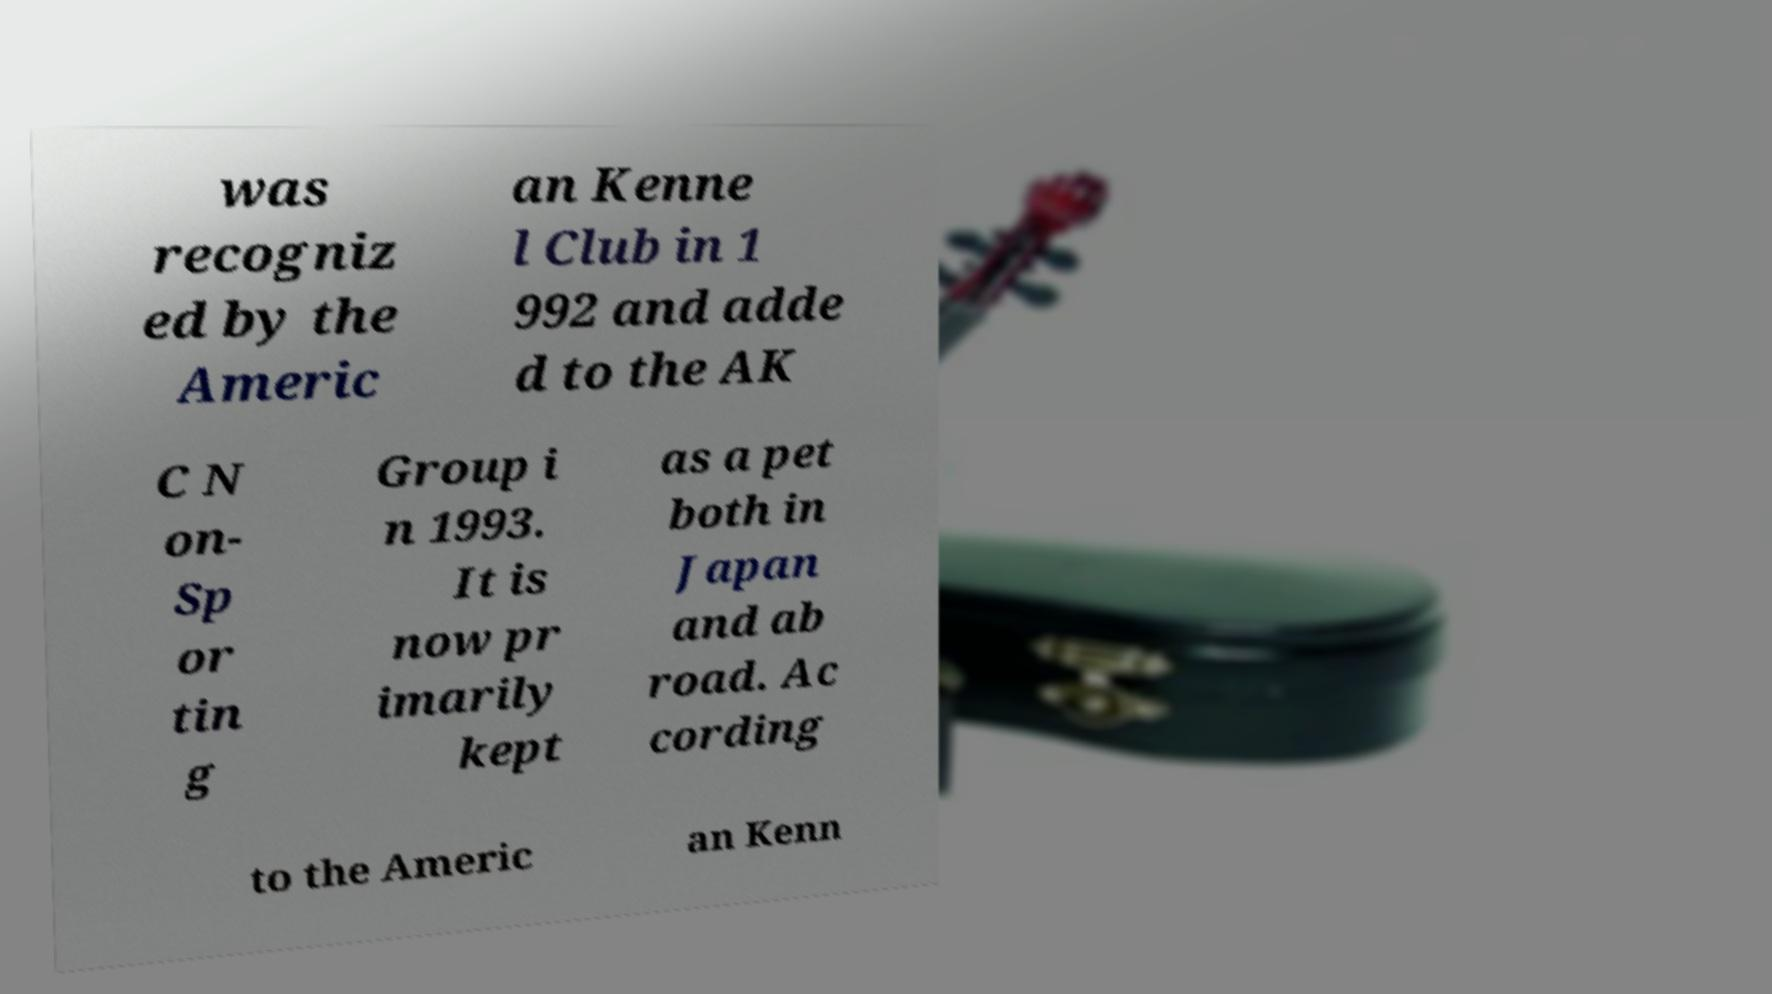For documentation purposes, I need the text within this image transcribed. Could you provide that? was recogniz ed by the Americ an Kenne l Club in 1 992 and adde d to the AK C N on- Sp or tin g Group i n 1993. It is now pr imarily kept as a pet both in Japan and ab road. Ac cording to the Americ an Kenn 